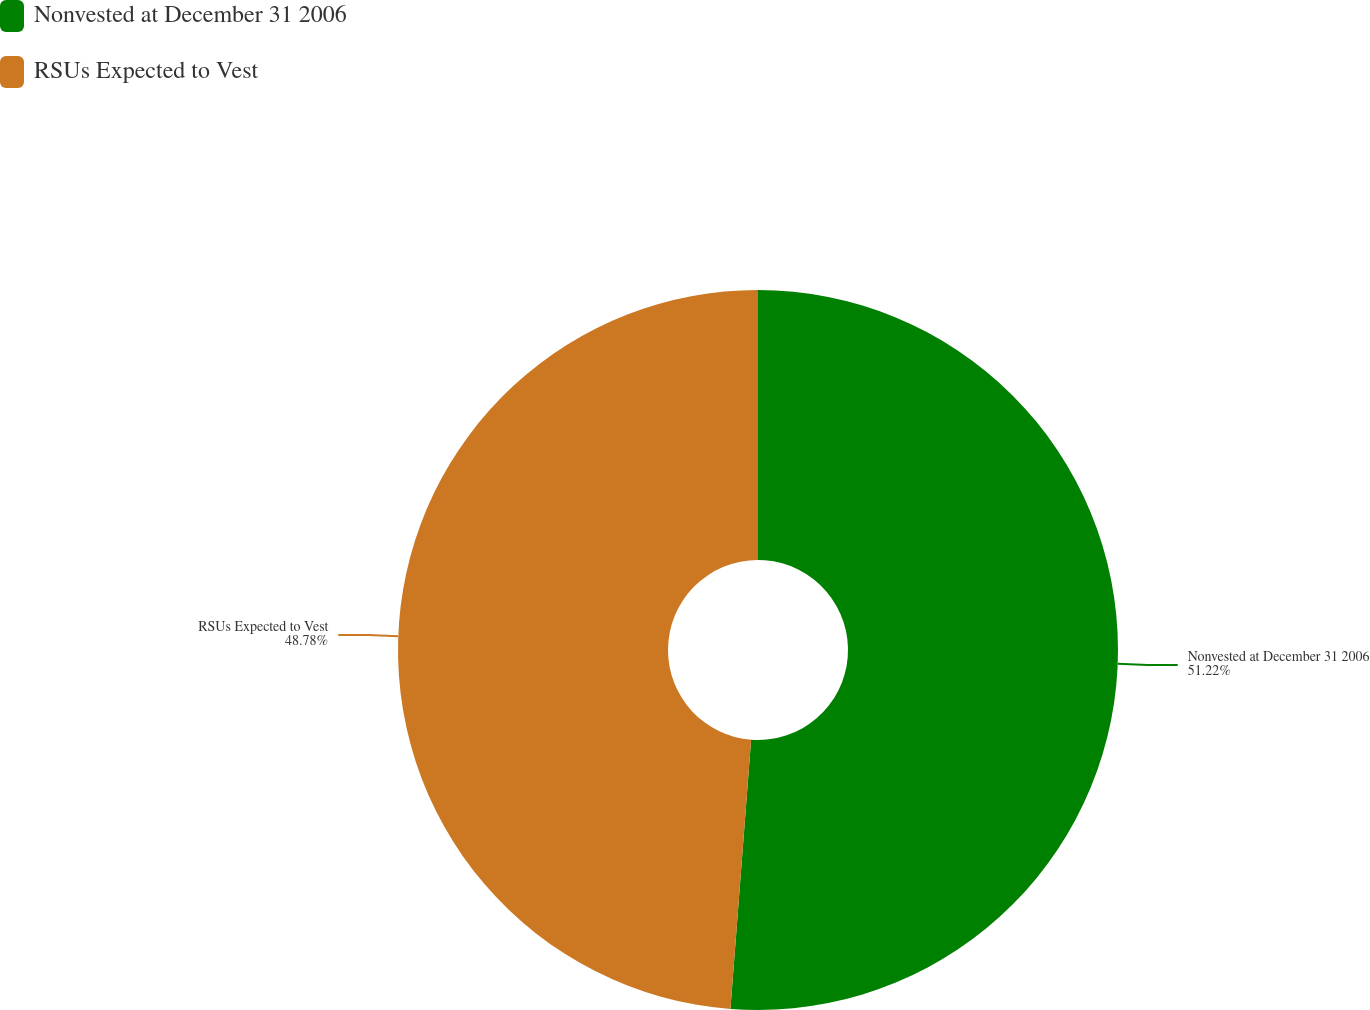Convert chart to OTSL. <chart><loc_0><loc_0><loc_500><loc_500><pie_chart><fcel>Nonvested at December 31 2006<fcel>RSUs Expected to Vest<nl><fcel>51.22%<fcel>48.78%<nl></chart> 